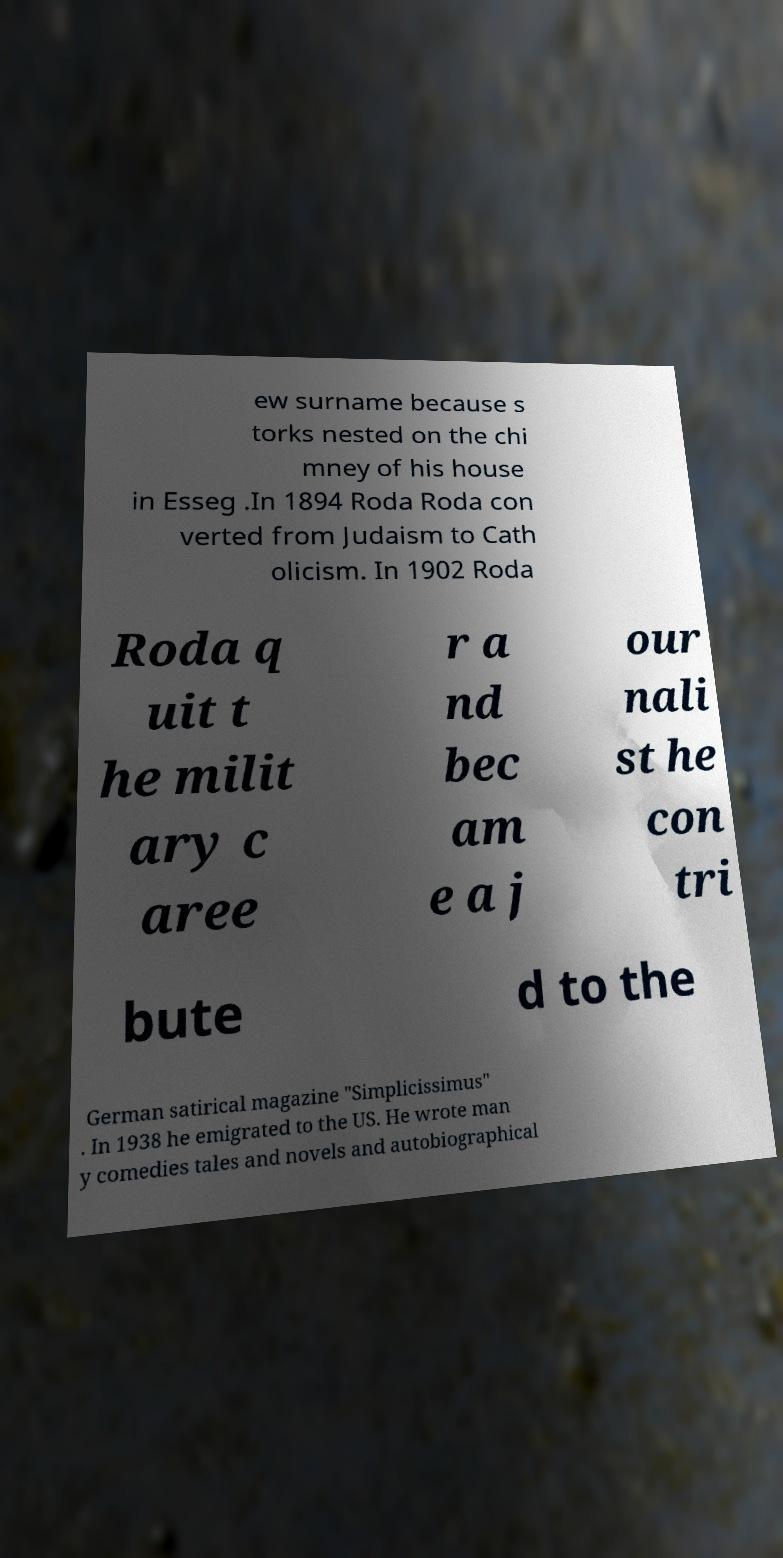What messages or text are displayed in this image? I need them in a readable, typed format. ew surname because s torks nested on the chi mney of his house in Esseg .In 1894 Roda Roda con verted from Judaism to Cath olicism. In 1902 Roda Roda q uit t he milit ary c aree r a nd bec am e a j our nali st he con tri bute d to the German satirical magazine "Simplicissimus" . In 1938 he emigrated to the US. He wrote man y comedies tales and novels and autobiographical 